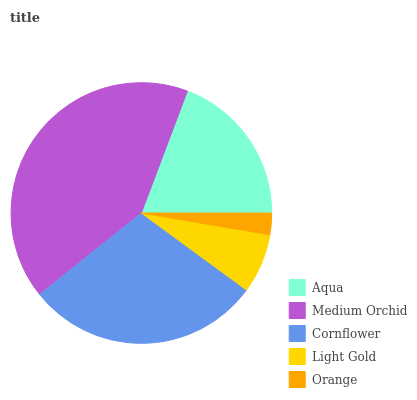Is Orange the minimum?
Answer yes or no. Yes. Is Medium Orchid the maximum?
Answer yes or no. Yes. Is Cornflower the minimum?
Answer yes or no. No. Is Cornflower the maximum?
Answer yes or no. No. Is Medium Orchid greater than Cornflower?
Answer yes or no. Yes. Is Cornflower less than Medium Orchid?
Answer yes or no. Yes. Is Cornflower greater than Medium Orchid?
Answer yes or no. No. Is Medium Orchid less than Cornflower?
Answer yes or no. No. Is Aqua the high median?
Answer yes or no. Yes. Is Aqua the low median?
Answer yes or no. Yes. Is Light Gold the high median?
Answer yes or no. No. Is Light Gold the low median?
Answer yes or no. No. 